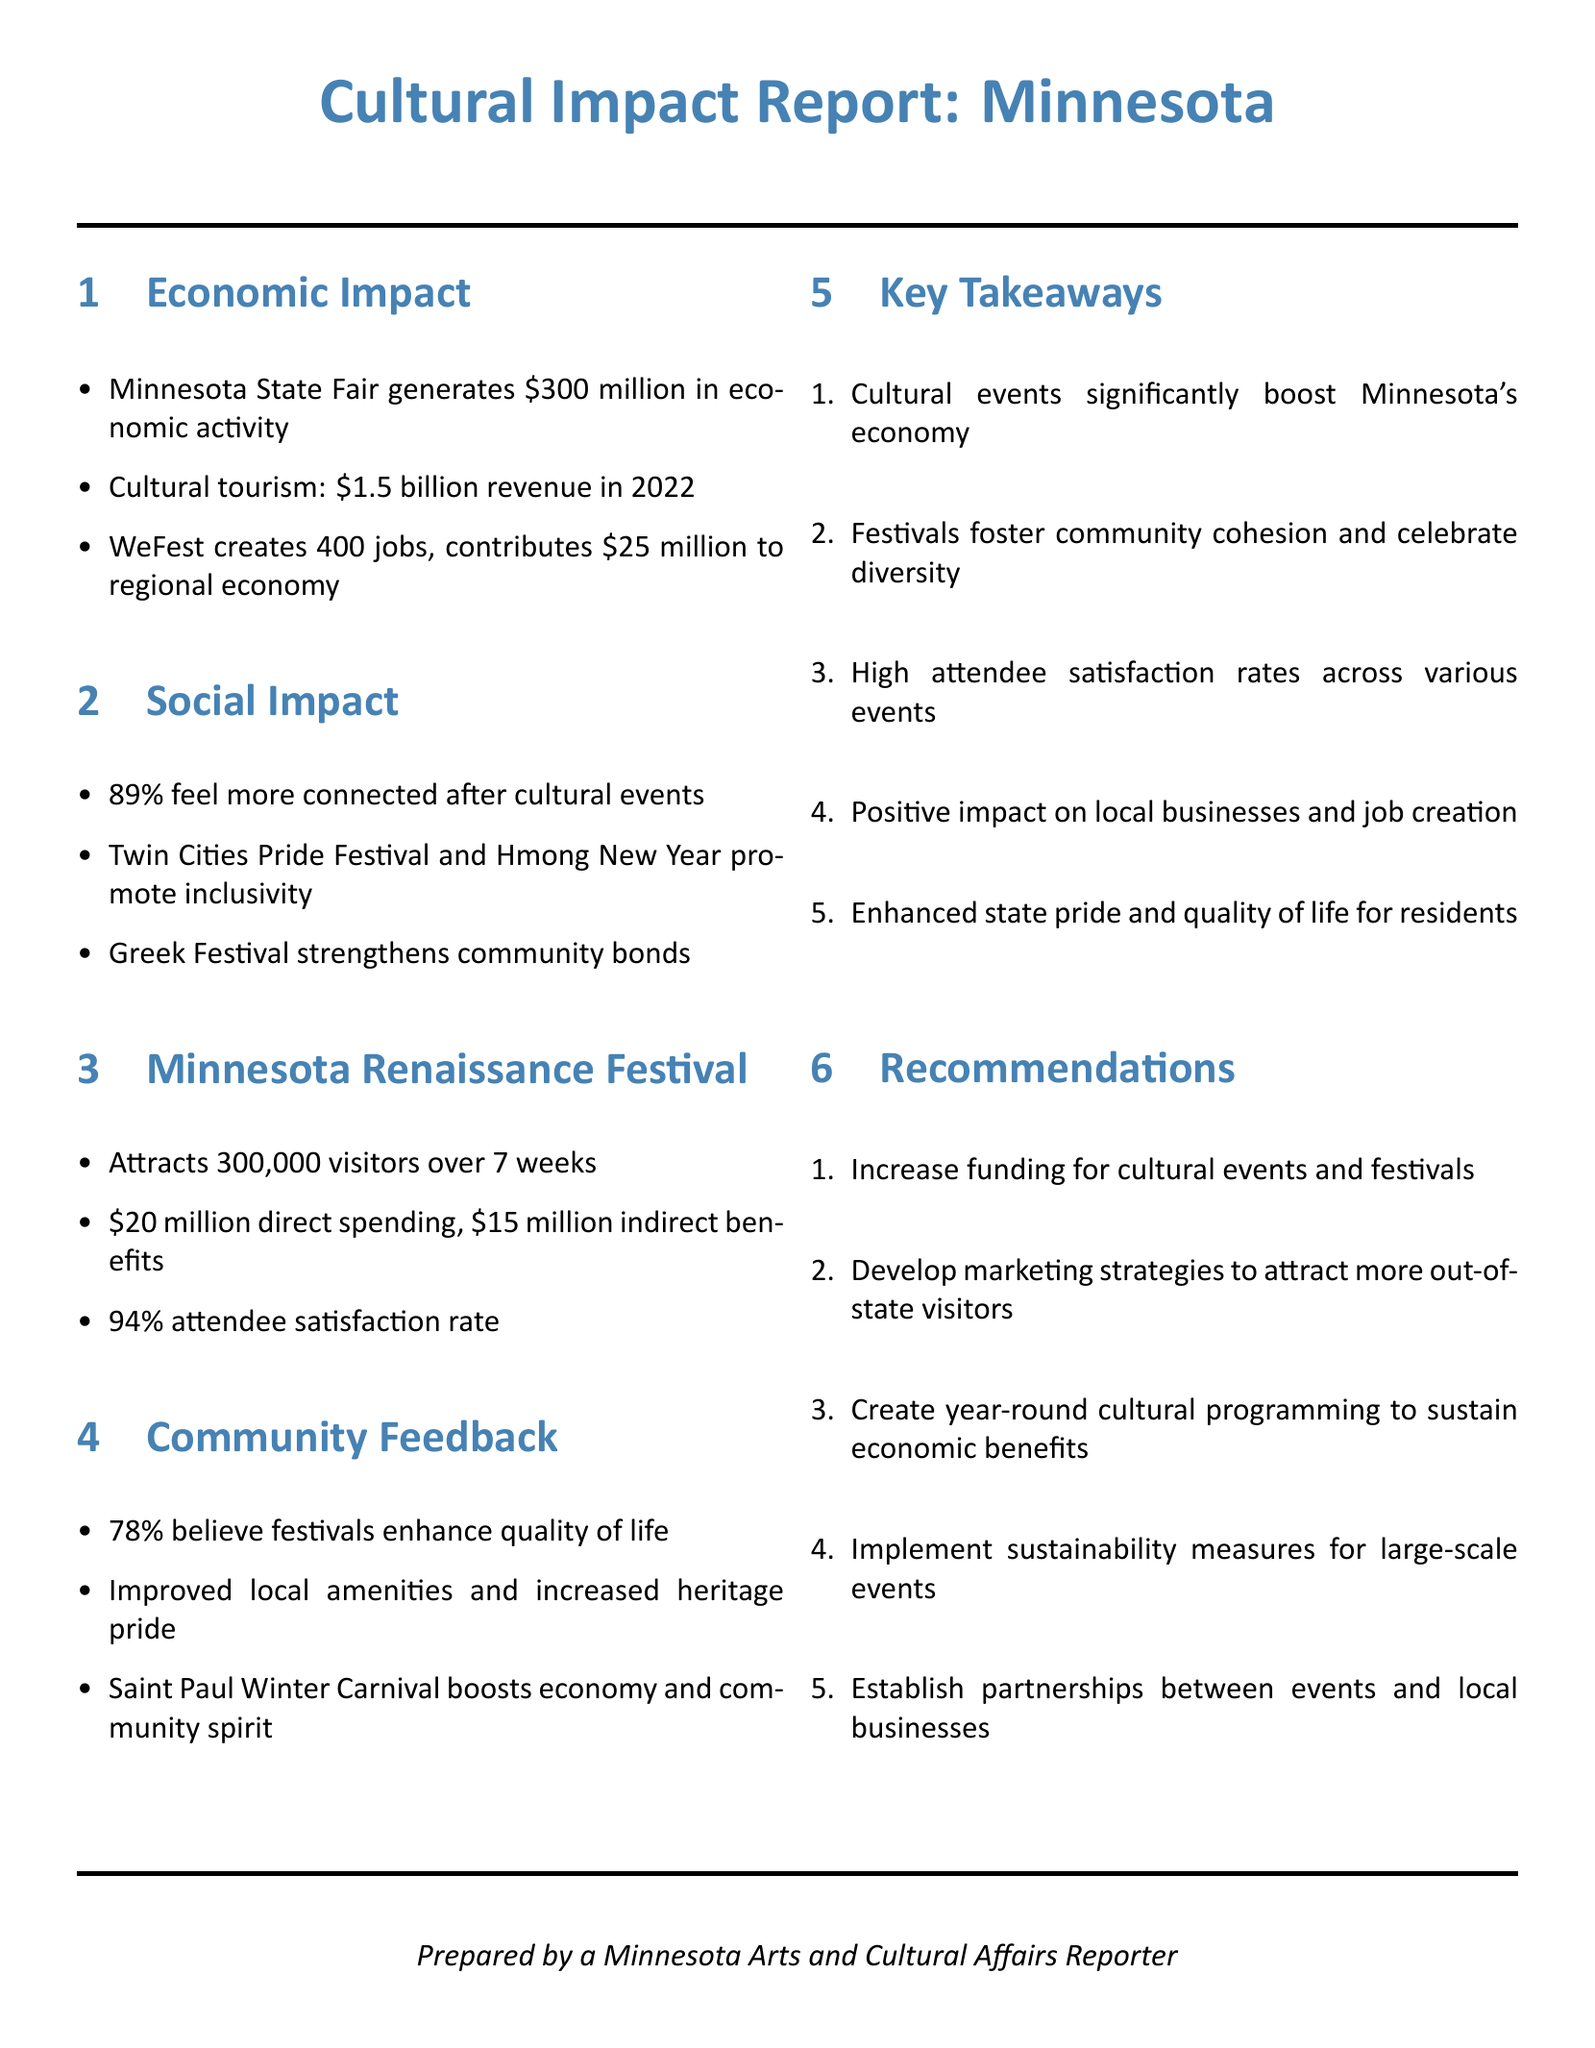What is the economic activity generated by the Minnesota State Fair? The document states that the Minnesota State Fair generates $300 million in economic activity.
Answer: $300 million What percentage of attendees felt more connected after cultural events? The document mentions that 89% of participants feel more connected after attending cultural events.
Answer: 89% How many visitors does the Minnesota Renaissance Festival attract? According to the document, the Minnesota Renaissance Festival attracts 300,000 visitors over 7 weeks.
Answer: 300,000 What is the job creation contribution of WeFest? The document indicates that WeFest creates 400 jobs.
Answer: 400 jobs What direct spending does the Minnesota Renaissance Festival generate? The document states that the festival generates $20 million in direct spending.
Answer: $20 million What is the attendee satisfaction rate at the Minnesota Renaissance Festival? The document mentions a 94% attendee satisfaction rate for the Minnesota Renaissance Festival.
Answer: 94% How many people believe festivals enhance the quality of life? According to the document, 78% believe that festivals enhance quality of life.
Answer: 78% What is one of the recommendations for cultural events? The document lists several recommendations, one of which is to increase funding for cultural events and festivals.
Answer: Increase funding What impact do cultural events have on local businesses? The document states that cultural events have a positive impact on local businesses.
Answer: Positive impact What social benefit is promoted by the Twin Cities Pride Festival? The document states that the Twin Cities Pride Festival promotes inclusivity.
Answer: Inclusivity 